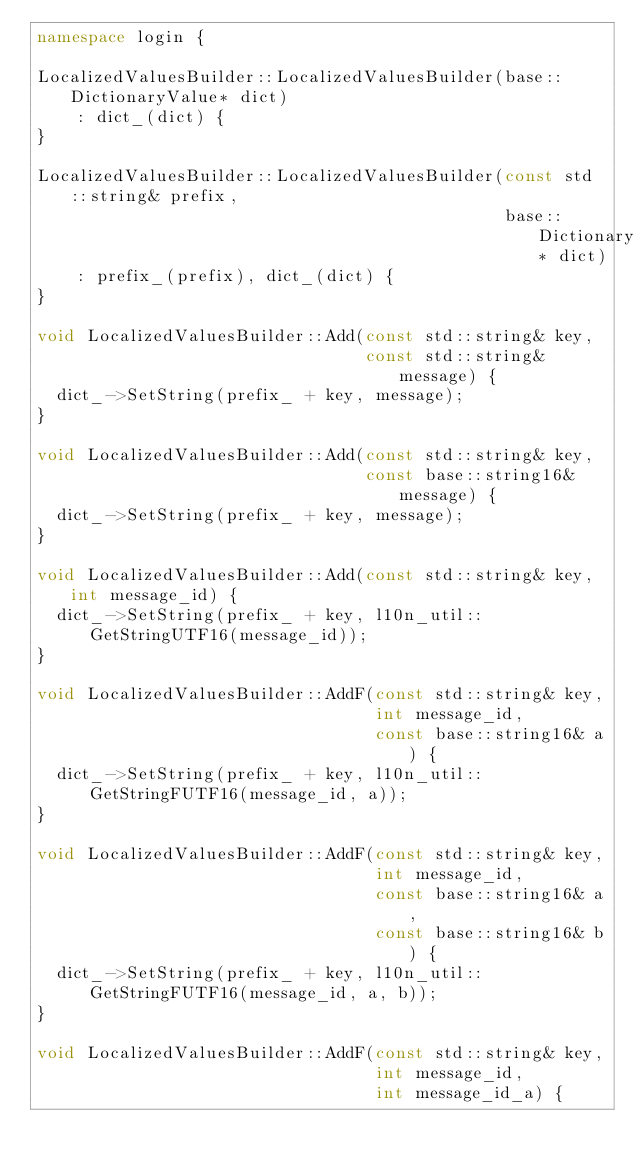Convert code to text. <code><loc_0><loc_0><loc_500><loc_500><_C++_>namespace login {

LocalizedValuesBuilder::LocalizedValuesBuilder(base::DictionaryValue* dict)
    : dict_(dict) {
}

LocalizedValuesBuilder::LocalizedValuesBuilder(const std::string& prefix,
                                               base::DictionaryValue* dict)
    : prefix_(prefix), dict_(dict) {
}

void LocalizedValuesBuilder::Add(const std::string& key,
                                 const std::string& message) {
  dict_->SetString(prefix_ + key, message);
}

void LocalizedValuesBuilder::Add(const std::string& key,
                                 const base::string16& message) {
  dict_->SetString(prefix_ + key, message);
}

void LocalizedValuesBuilder::Add(const std::string& key, int message_id) {
  dict_->SetString(prefix_ + key, l10n_util::GetStringUTF16(message_id));
}

void LocalizedValuesBuilder::AddF(const std::string& key,
                                  int message_id,
                                  const base::string16& a) {
  dict_->SetString(prefix_ + key, l10n_util::GetStringFUTF16(message_id, a));
}

void LocalizedValuesBuilder::AddF(const std::string& key,
                                  int message_id,
                                  const base::string16& a,
                                  const base::string16& b) {
  dict_->SetString(prefix_ + key, l10n_util::GetStringFUTF16(message_id, a, b));
}

void LocalizedValuesBuilder::AddF(const std::string& key,
                                  int message_id,
                                  int message_id_a) {</code> 